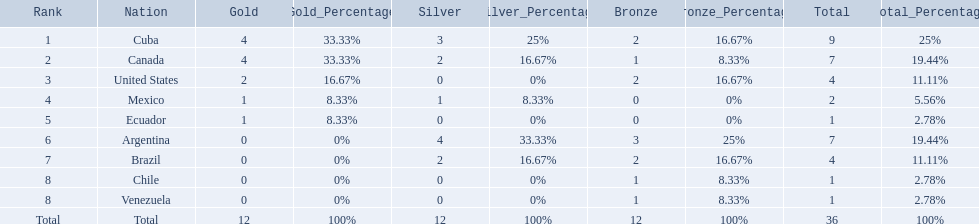Which countries won medals at the 2011 pan american games for the canoeing event? Cuba, Canada, United States, Mexico, Ecuador, Argentina, Brazil, Chile, Venezuela. Which of these countries won bronze medals? Cuba, Canada, United States, Argentina, Brazil, Chile, Venezuela. Of these countries, which won the most bronze medals? Argentina. 